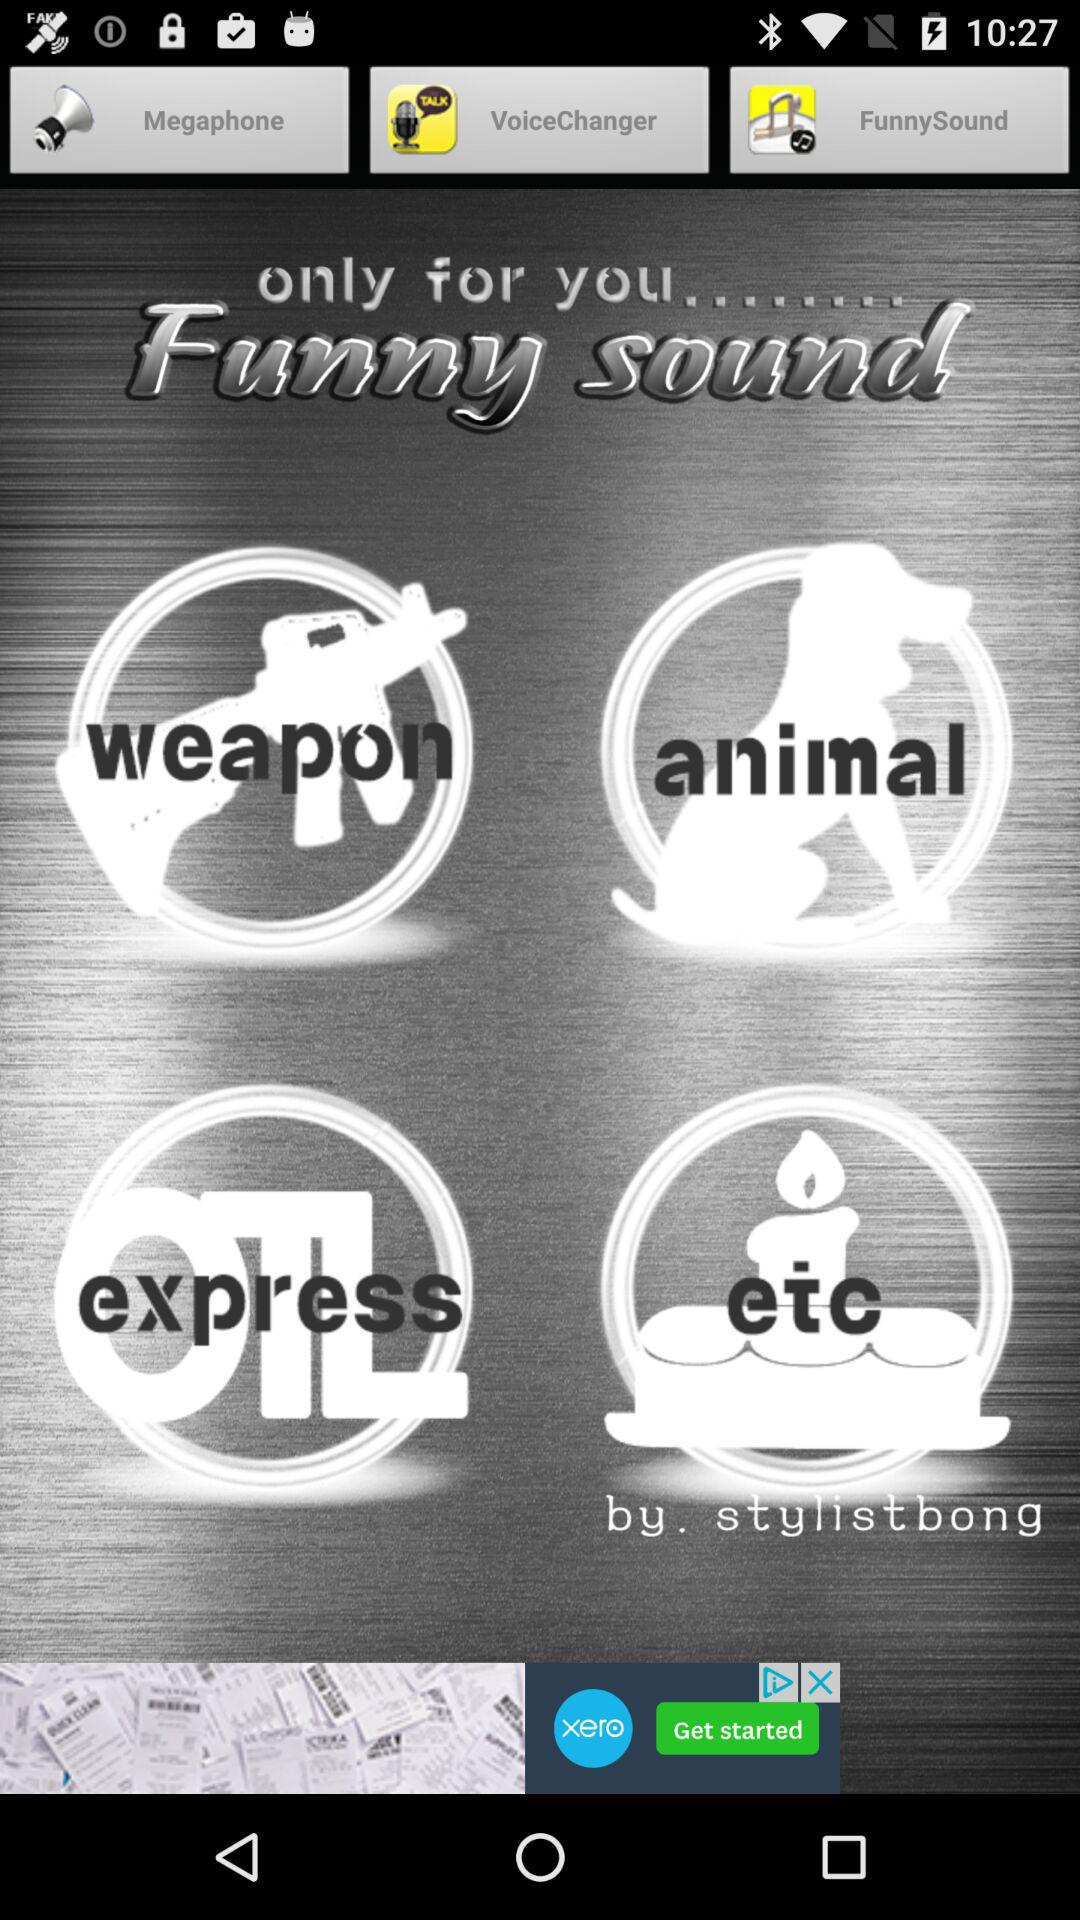By whom has the application been developed? The application has been developed by "stylistbong". 